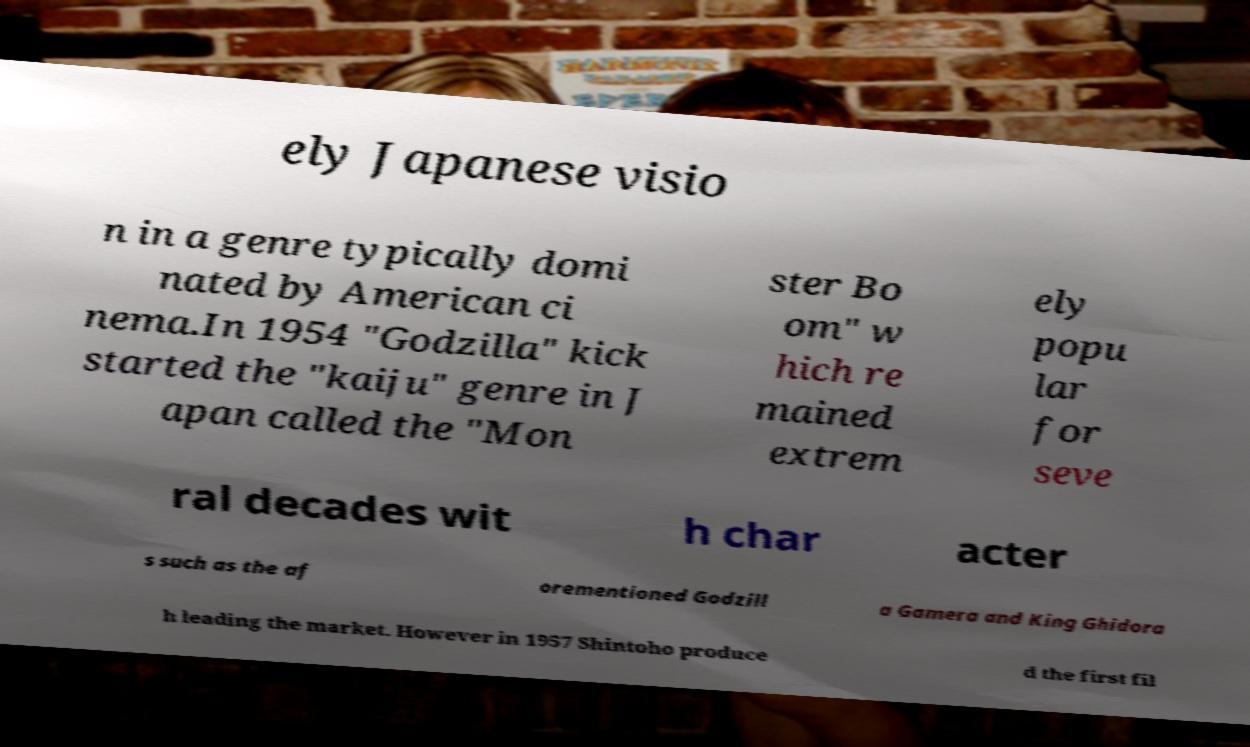Can you accurately transcribe the text from the provided image for me? ely Japanese visio n in a genre typically domi nated by American ci nema.In 1954 "Godzilla" kick started the "kaiju" genre in J apan called the "Mon ster Bo om" w hich re mained extrem ely popu lar for seve ral decades wit h char acter s such as the af orementioned Godzill a Gamera and King Ghidora h leading the market. However in 1957 Shintoho produce d the first fil 